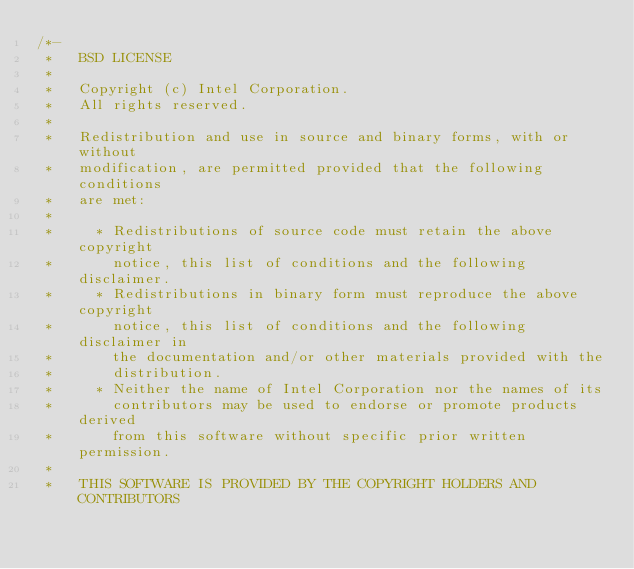Convert code to text. <code><loc_0><loc_0><loc_500><loc_500><_C_>/*-
 *   BSD LICENSE
 *
 *   Copyright (c) Intel Corporation.
 *   All rights reserved.
 *
 *   Redistribution and use in source and binary forms, with or without
 *   modification, are permitted provided that the following conditions
 *   are met:
 *
 *     * Redistributions of source code must retain the above copyright
 *       notice, this list of conditions and the following disclaimer.
 *     * Redistributions in binary form must reproduce the above copyright
 *       notice, this list of conditions and the following disclaimer in
 *       the documentation and/or other materials provided with the
 *       distribution.
 *     * Neither the name of Intel Corporation nor the names of its
 *       contributors may be used to endorse or promote products derived
 *       from this software without specific prior written permission.
 *
 *   THIS SOFTWARE IS PROVIDED BY THE COPYRIGHT HOLDERS AND CONTRIBUTORS</code> 